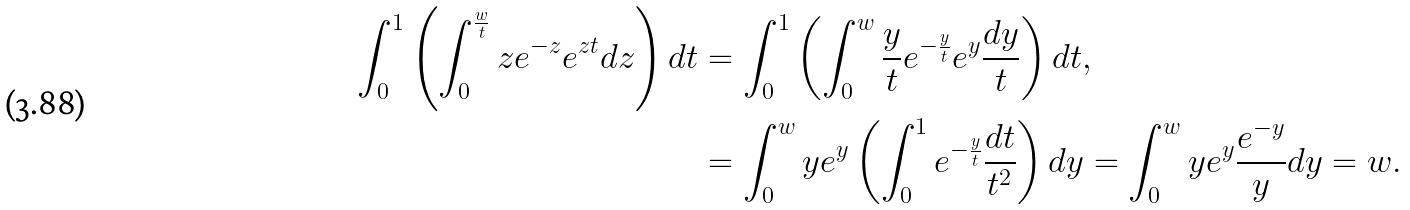<formula> <loc_0><loc_0><loc_500><loc_500>\int _ { 0 } ^ { 1 } \left ( \int _ { 0 } ^ { \frac { w } { t } } z e ^ { - z } e ^ { z t } d z \right ) d t & = \int _ { 0 } ^ { 1 } \left ( \int _ { 0 } ^ { w } \frac { y } { t } e ^ { - \frac { y } { t } } e ^ { y } \frac { d y } { t } \right ) d t , \\ & = \int _ { 0 } ^ { w } y e ^ { y } \left ( \int _ { 0 } ^ { 1 } e ^ { - \frac { y } { t } } \frac { d t } { t ^ { 2 } } \right ) d y = \int _ { 0 } ^ { w } y e ^ { y } \frac { e ^ { - y } } { y } d y = w .</formula> 